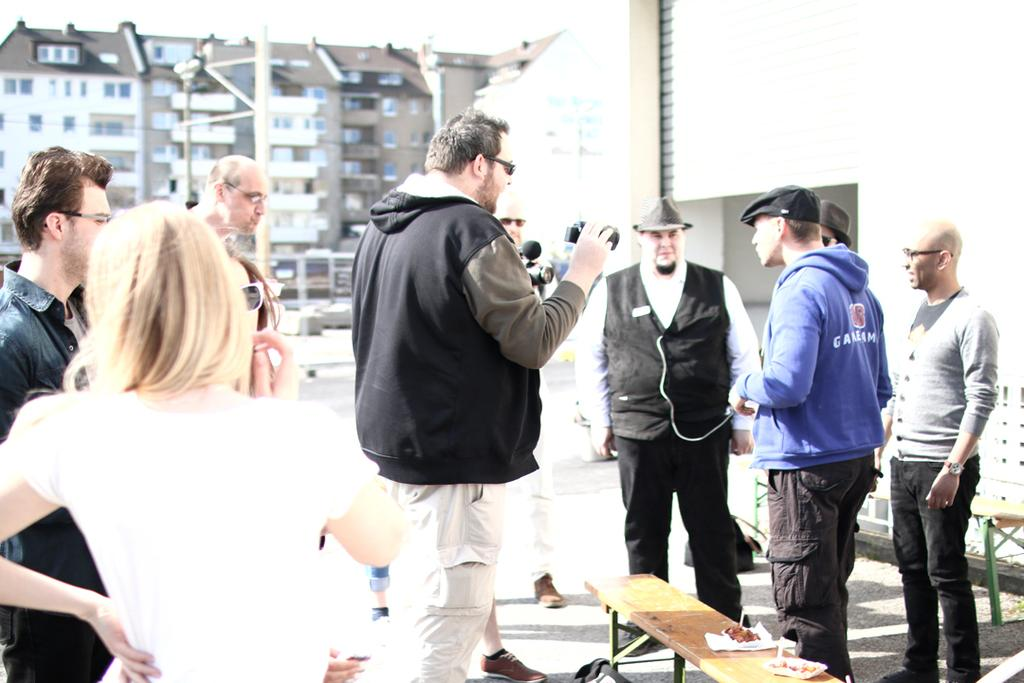What are the people in the image doing? There are persons standing in the image. What is the person in the center holding? The center person is holding a camera. What can be seen in the background of the image? There is a building and the sky visible in the background of the image. What month is it in the image? The month cannot be determined from the image, as there is no information about the time of year. Is there a playground visible in the image? No, there is no playground present in the image. 